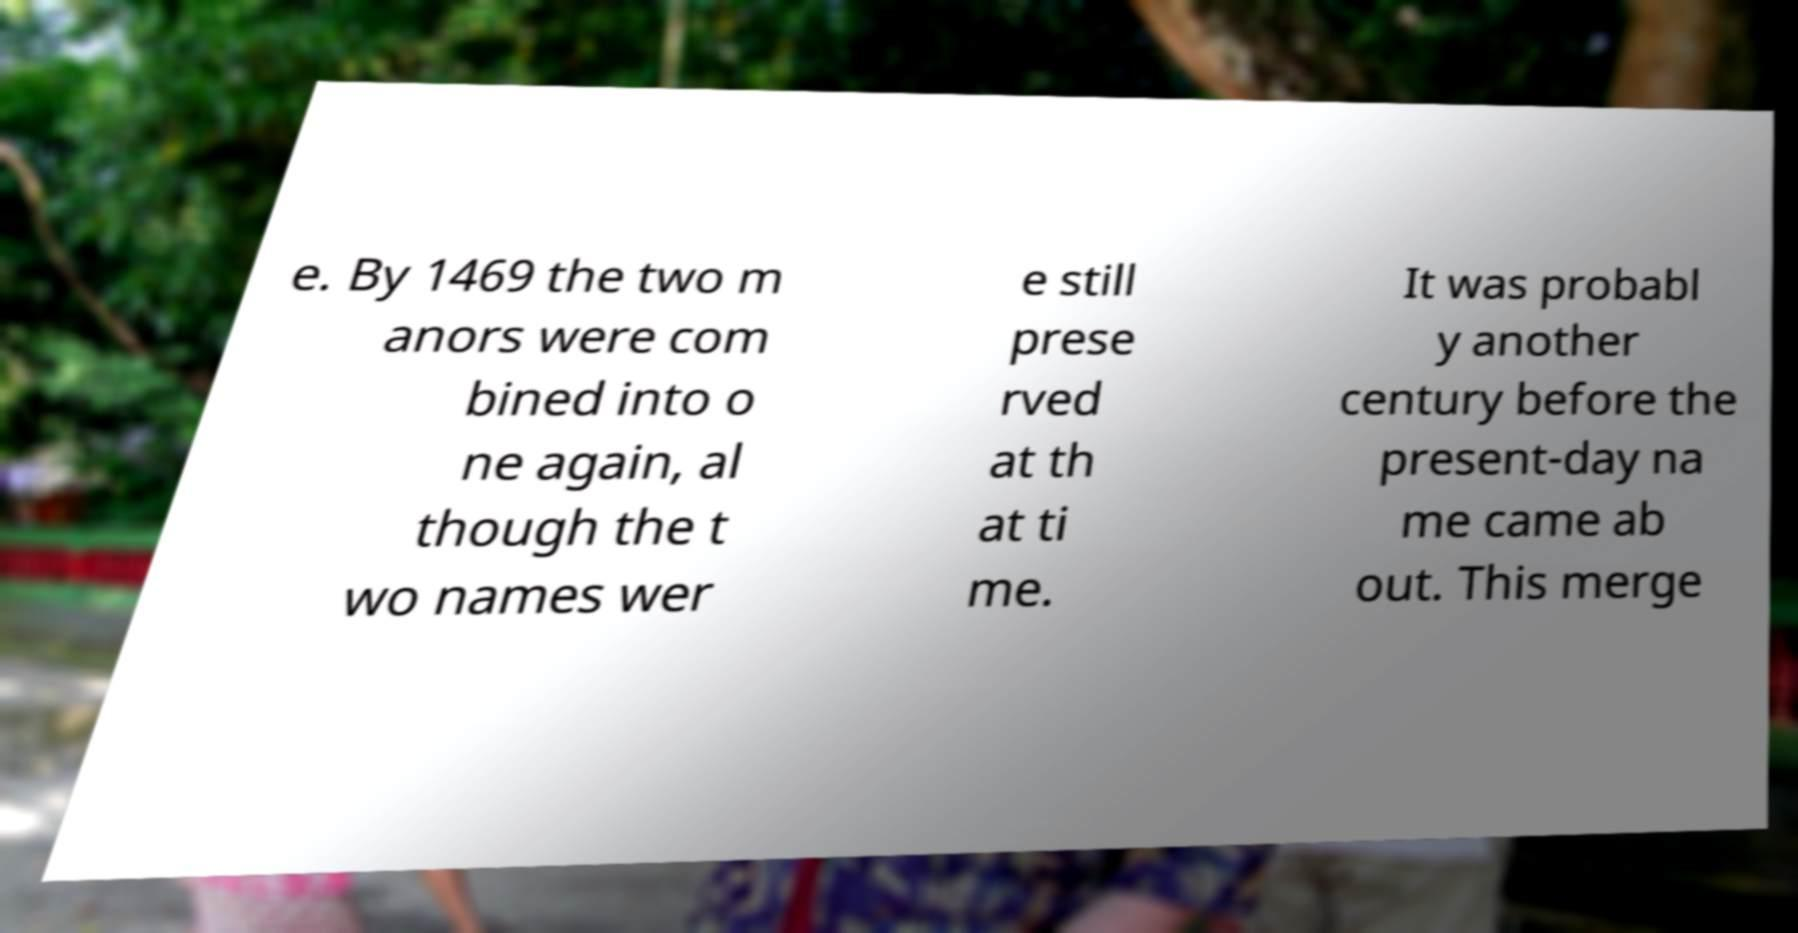What messages or text are displayed in this image? I need them in a readable, typed format. e. By 1469 the two m anors were com bined into o ne again, al though the t wo names wer e still prese rved at th at ti me. It was probabl y another century before the present-day na me came ab out. This merge 